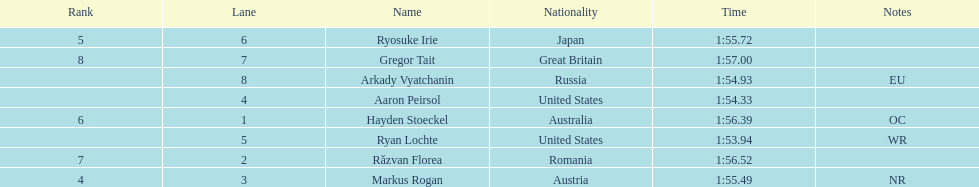Did austria or russia rank higher? Russia. 